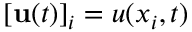<formula> <loc_0><loc_0><loc_500><loc_500>[ u ( t ) ] _ { i } = u ( x _ { i } , t )</formula> 